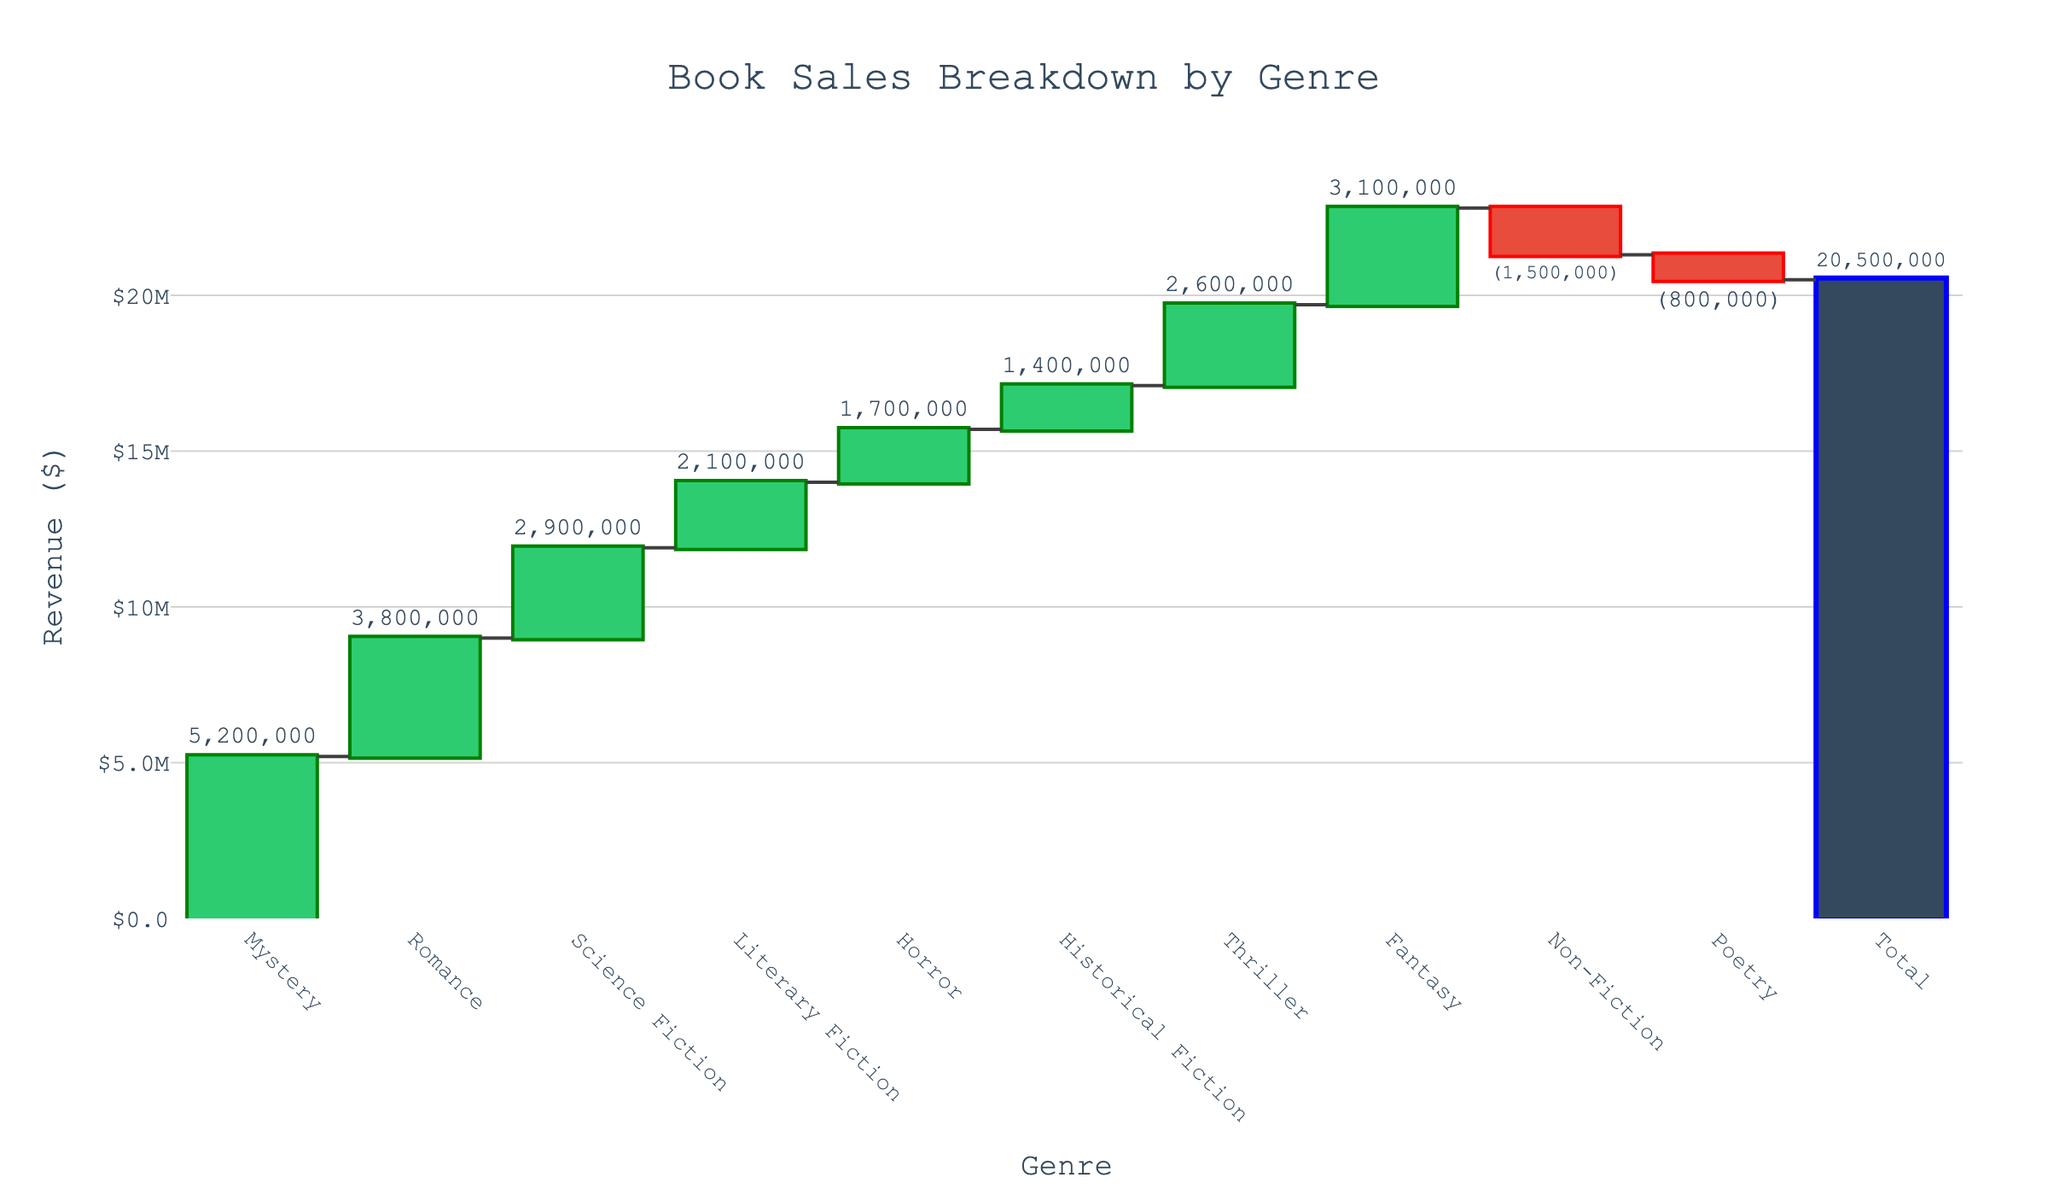what is the highest revenue genre? The Mystery genre has the highest bar in the chart, indicating the highest revenue.
Answer: Mystery What is the total revenue shown in the chart? The total revenue is directly shown at the end of the chart as 20,500,000.
Answer: 20,500,000 Which genres have negative revenues? The genres with bars going downward below the zero line are Non-Fiction and Poetry.
Answer: Non-Fiction, Poetry By how much does the revenue from Fantasy exceed that from Horror? Fantasy has a revenue of 3,100,000 and Horror has a revenue of 1,700,000. Subtracting these gives 3,100,000 - 1,700,000 = 1,400,000.
Answer: 1,400,000 What is the cumulative revenue after including Science Fiction and Literary Fiction? The cumulative revenue after adding Science Fiction (2,900,000) and Literary Fiction (2,100,000) is 5,200,000 + 3,800,000 + 2,900,000 + 2,100,000 = 13,000,000.
Answer: 13,000,000 What is the average revenue of genres with positive values? The positive revenue genres are Mystery, Romance, Science Fiction, Literary Fiction, Horror, Historical Fiction, Thriller, Fantasy. Their revenues sum to 5,200,000 + 3,800,000 + 2,900,000 + 2,100,000 + 1,700,000 + 1,400,000 + 2,600,000 + 3,100,000 = 22,800,000. There are 8 such genres, so the average is 22,800,000 / 8 = 2,850,000.
Answer: 2,850,000 Which genre contributes the lowest positive revenue? The Historical Fiction genre, with a revenue of 1,400,000, has the lowest positive bar height.
Answer: Historical Fiction What is the net impact of Non-Fiction and Poetry on the total revenue? Non-Fiction has a revenue of -1,500,000 and Poetry has -800,000. Adding these gives -1,500,000 + (-800,000) = -2,300,000.
Answer: -2,300,000 Is the revenue from Thriller greater than or equal to that from Historical Fiction and Horror combined? Thriller revenue is 2,600,000. Historical Fiction and Horror combined are 1,400,000 + 1,700,000 = 3,100,000. 2,600,000 is not greater than 3,100,000.
Answer: No 